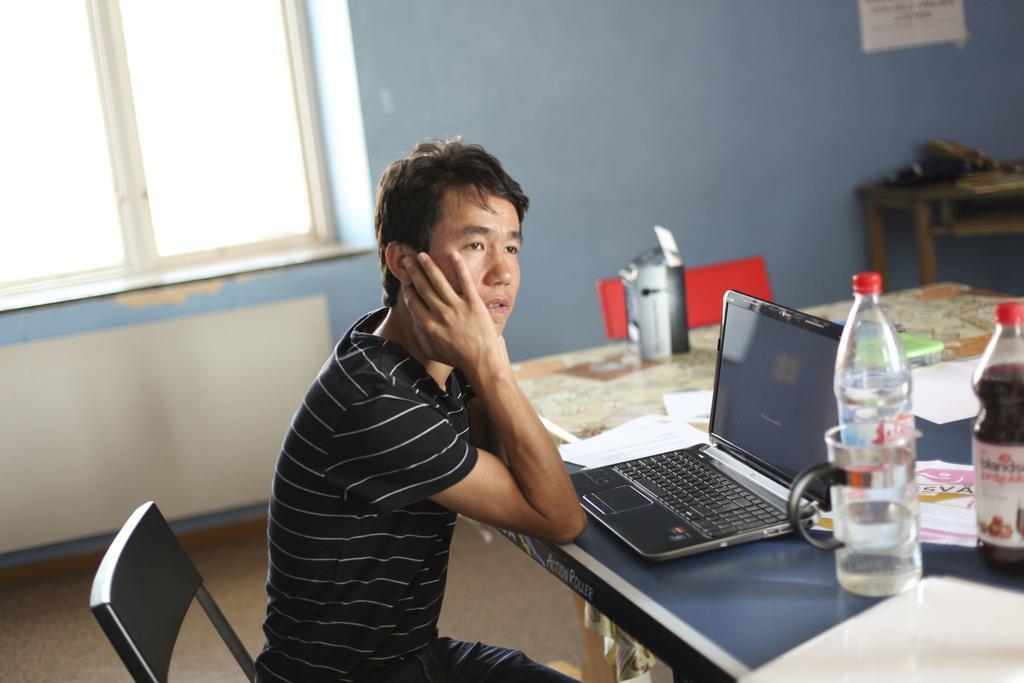How would you summarize this image in a sentence or two? In this picture we can see man sitting on chair keeping his hands on table and on table we can see laptop, bottle, cup, papers and beside to him we can see wall with poster, window. 